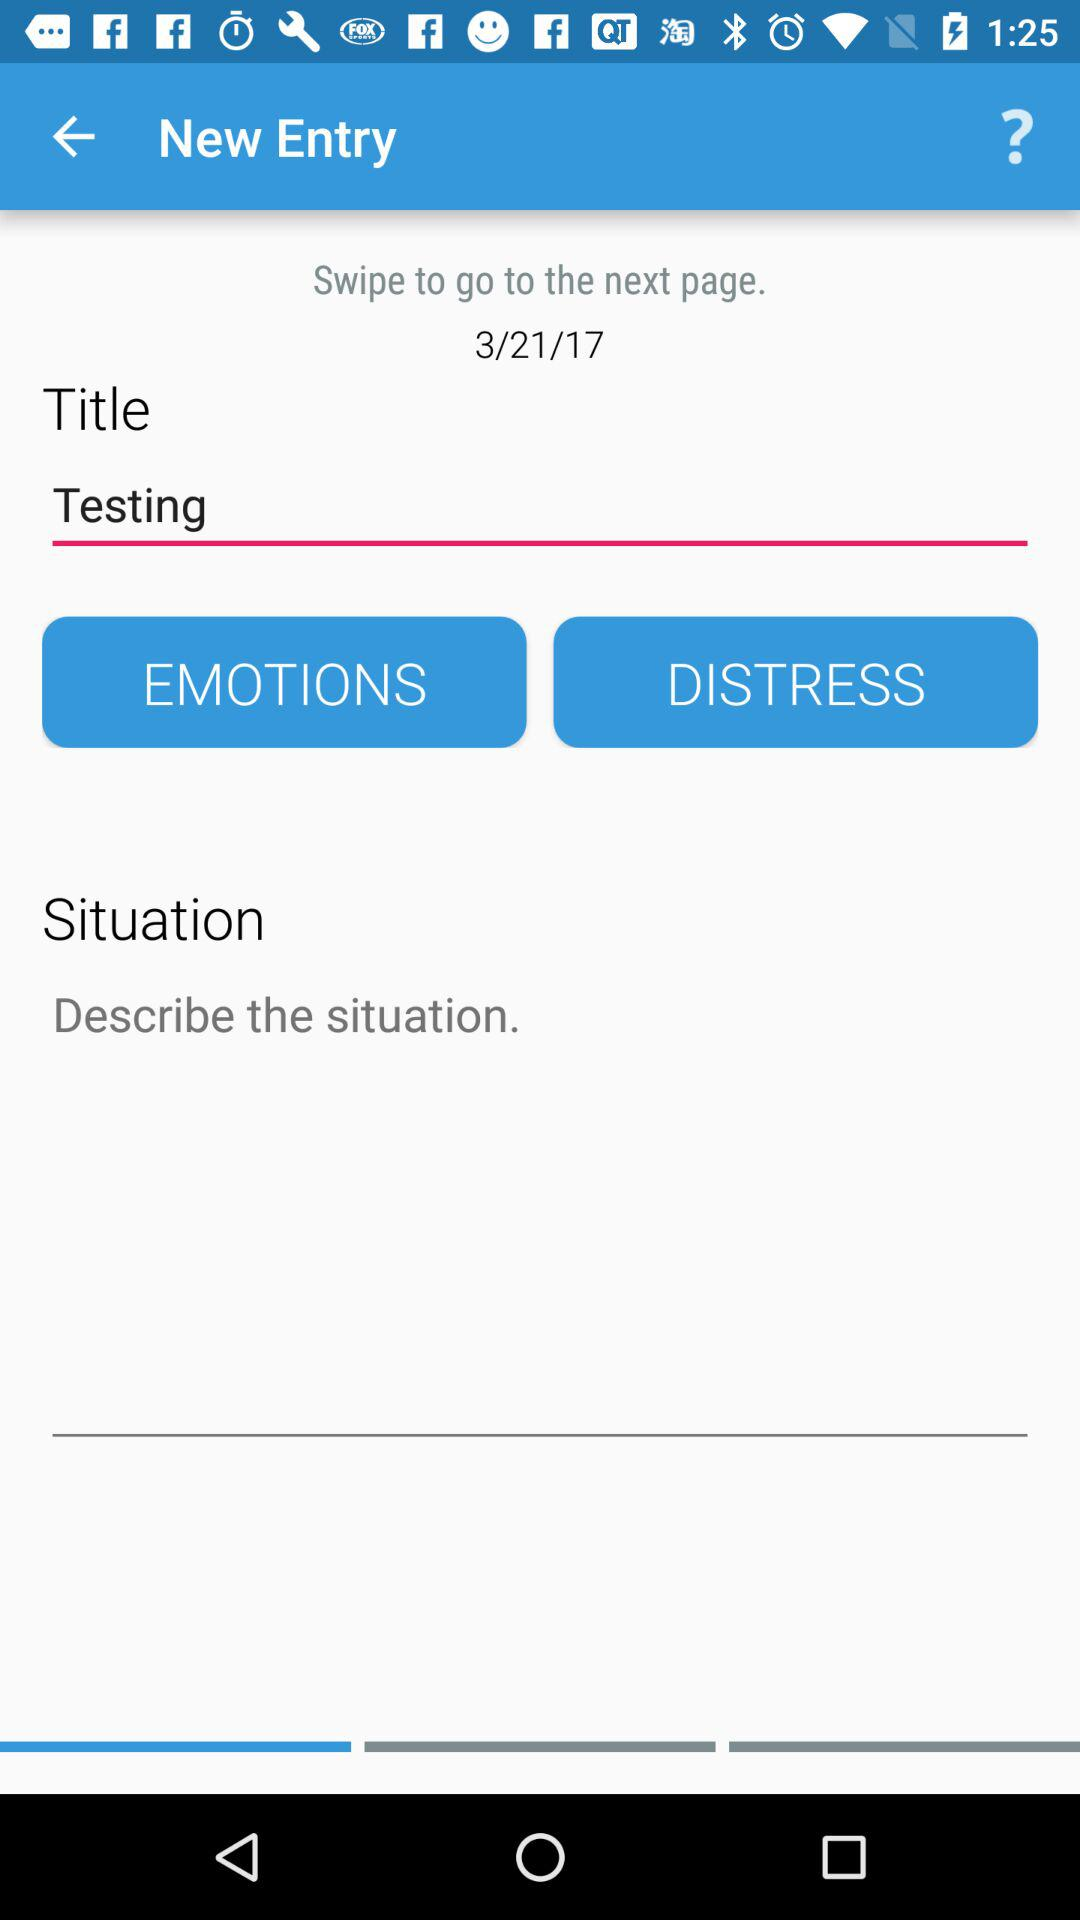What is the title of the page? The title of the page is "Testing". 